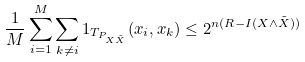Convert formula to latex. <formula><loc_0><loc_0><loc_500><loc_500>\frac { 1 } { M } \sum _ { i = 1 } ^ { M } \sum _ { k \neq i } 1 _ { T _ { P _ { X \tilde { X } } } } ( x _ { i } , x _ { k } ) \leq 2 ^ { n ( R - I ( X \wedge \tilde { X } ) ) }</formula> 